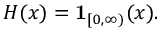Convert formula to latex. <formula><loc_0><loc_0><loc_500><loc_500>H ( x ) = 1 _ { [ 0 , \infty ) } ( x ) .</formula> 